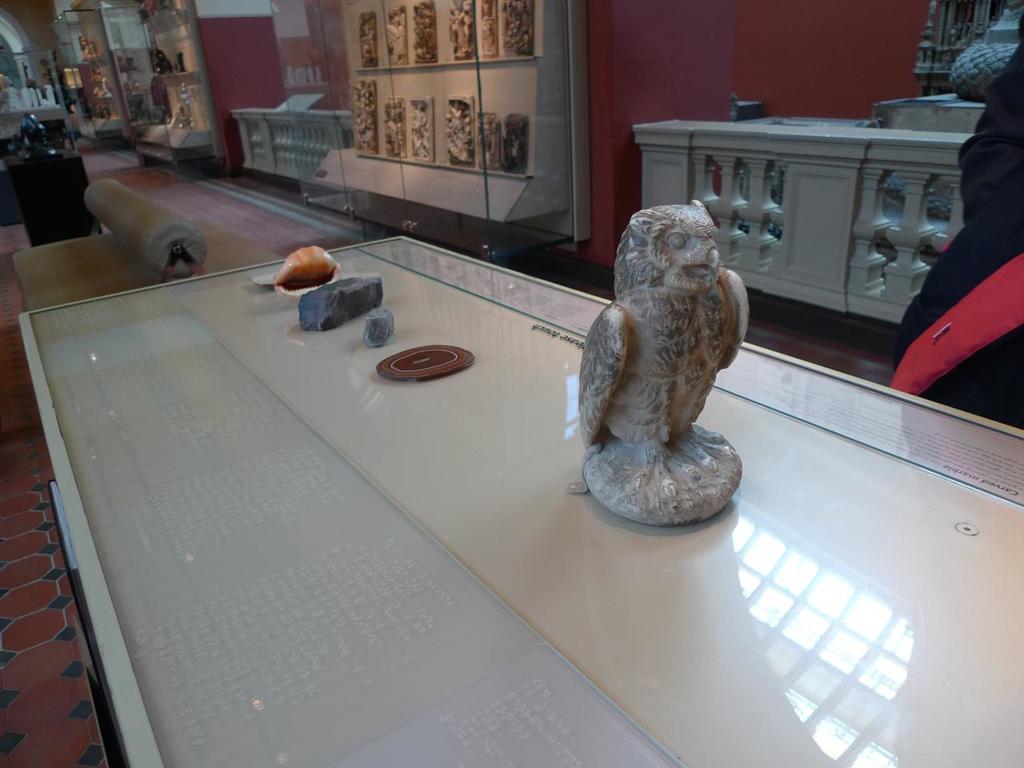Can you describe this image briefly? In this picture here we see a table on which an eagle statue is present. Here we also have a seashell. Behind the table, there is a sofa. Behind sofa we have another small table. In the background we have glass window inside which some statues are present. It looks like a big room. 